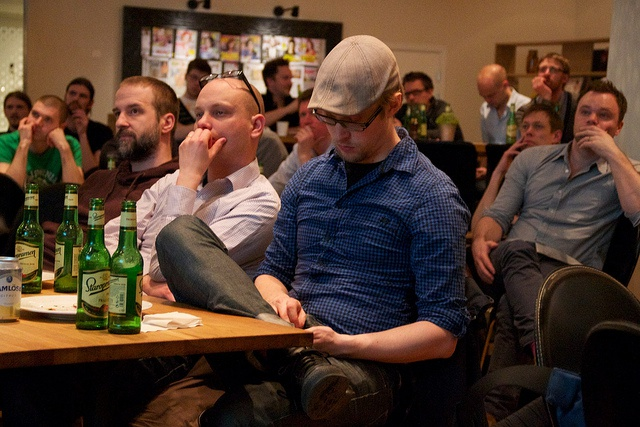Describe the objects in this image and their specific colors. I can see people in olive, black, navy, maroon, and gray tones, people in olive, black, tan, maroon, and brown tones, people in olive, black, gray, maroon, and brown tones, dining table in olive, black, orange, and maroon tones, and people in olive, black, maroon, brown, and salmon tones in this image. 